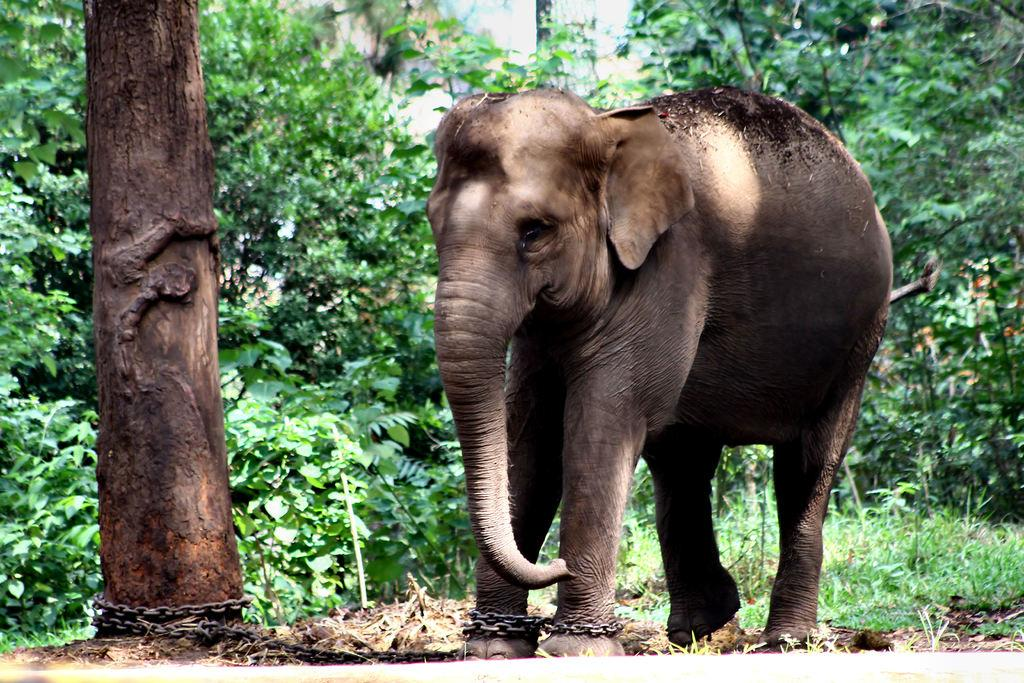What animal is the main subject of the image? There is an elephant in the image. What is the elephant doing in the image? The elephant is standing in the image. How is the elephant secured in the image? The elephant is tied with an iron chain. What can be seen in the foreground of the image? There is a tree trunk in the image. What type of environment is depicted in the background of the image? There are trees and plants in the background of the image. What type of ground is visible in the image? The image appears to depict grass. How many pickles are hanging from the tree trunk in the image? There are no pickles present in the image; it features an elephant, a tree trunk, and various background elements. Can you describe the wings of the chickens in the image? There are no chickens or wings present in the image; it features an elephant, a tree trunk, and various background elements. 